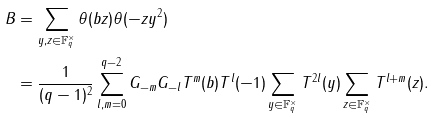Convert formula to latex. <formula><loc_0><loc_0><loc_500><loc_500>B & = \sum _ { y , z \in \mathbb { F } _ { q } ^ { \times } } \theta ( b z ) \theta ( - z y ^ { 2 } ) \\ & = \frac { 1 } { ( q - 1 ) ^ { 2 } } \sum _ { l , m = 0 } ^ { q - 2 } G _ { - m } G _ { - l } T ^ { m } ( b ) T ^ { l } ( - 1 ) \sum _ { y \in \mathbb { F } _ { q } ^ { \times } } T ^ { 2 l } ( y ) \sum _ { z \in \mathbb { F } _ { q } ^ { \times } } T ^ { l + m } ( z ) .</formula> 